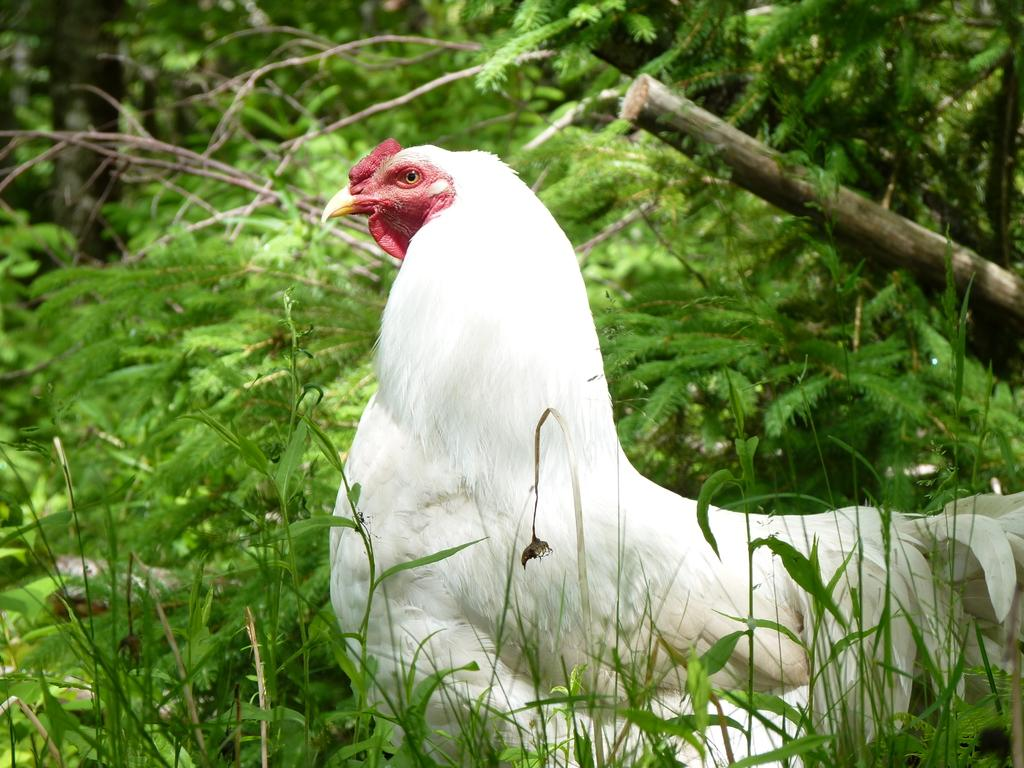What type of animal is in the image? There is a white hen in the image. Can you describe the background of the image? The background of the image is blurry. What type of natural environment is visible in the image? There is greenery visible in the image. What type of fan is visible in the image? There is no fan present in the image. What type of zinc object can be seen in the image? There is no zinc object present in the image. How many books are visible in the image? There are no books present in the image. 